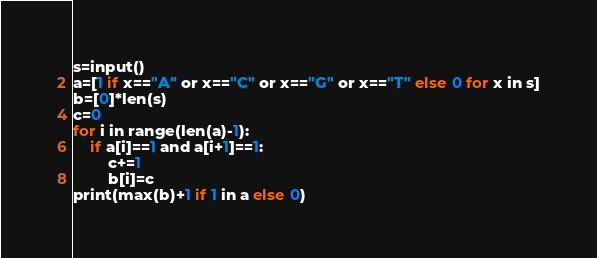<code> <loc_0><loc_0><loc_500><loc_500><_Python_>s=input()
a=[1 if x=="A" or x=="C" or x=="G" or x=="T" else 0 for x in s]
b=[0]*len(s)
c=0
for i in range(len(a)-1):
    if a[i]==1 and a[i+1]==1:
        c+=1
        b[i]=c
print(max(b)+1 if 1 in a else 0)</code> 